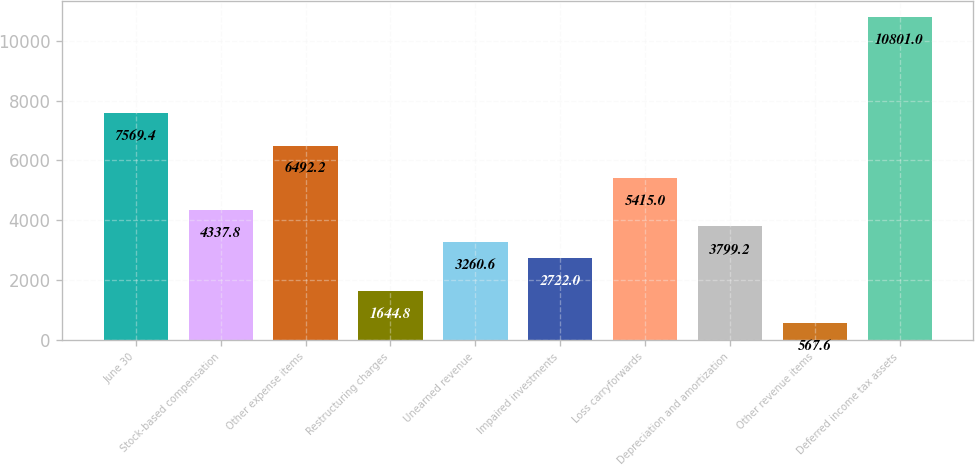Convert chart. <chart><loc_0><loc_0><loc_500><loc_500><bar_chart><fcel>June 30<fcel>Stock-based compensation<fcel>Other expense items<fcel>Restructuring charges<fcel>Unearned revenue<fcel>Impaired investments<fcel>Loss carryforwards<fcel>Depreciation and amortization<fcel>Other revenue items<fcel>Deferred income tax assets<nl><fcel>7569.4<fcel>4337.8<fcel>6492.2<fcel>1644.8<fcel>3260.6<fcel>2722<fcel>5415<fcel>3799.2<fcel>567.6<fcel>10801<nl></chart> 